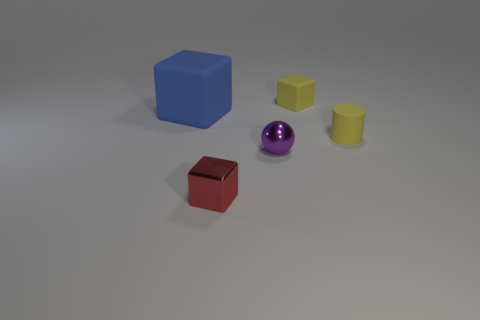What shape is the tiny rubber thing that is the same color as the small matte cylinder? cube 